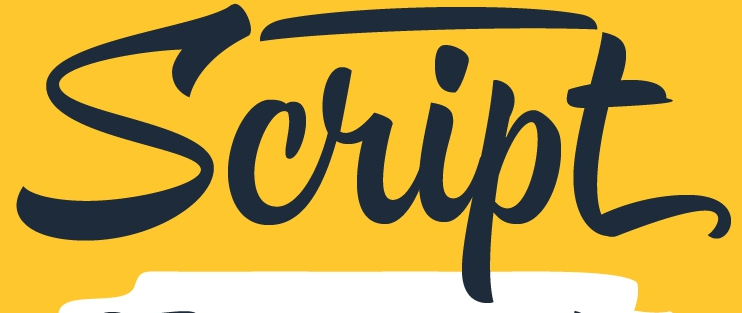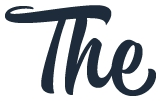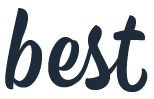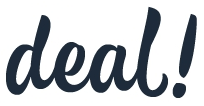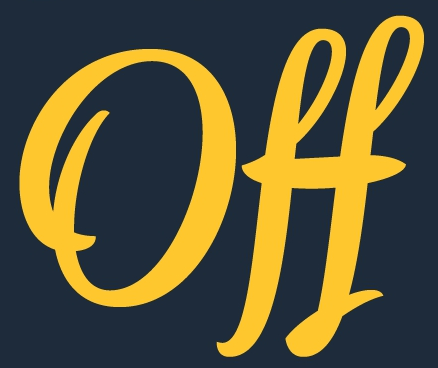Read the text from these images in sequence, separated by a semicolon. Script; The; best; deal!; Off 